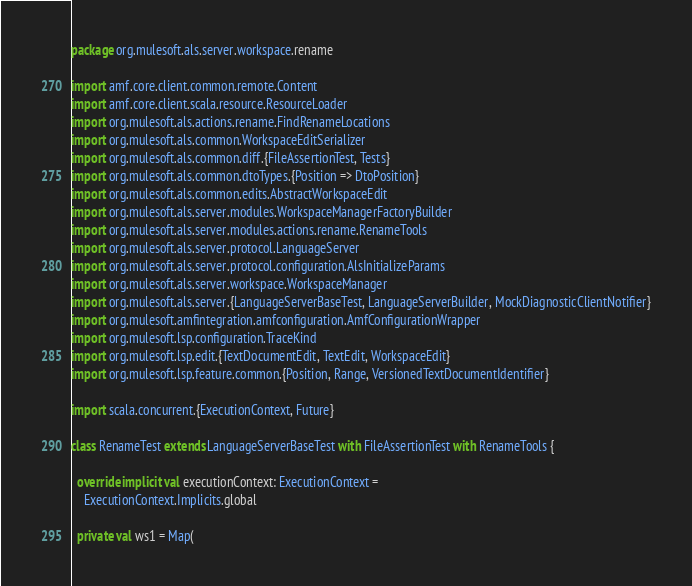<code> <loc_0><loc_0><loc_500><loc_500><_Scala_>package org.mulesoft.als.server.workspace.rename

import amf.core.client.common.remote.Content
import amf.core.client.scala.resource.ResourceLoader
import org.mulesoft.als.actions.rename.FindRenameLocations
import org.mulesoft.als.common.WorkspaceEditSerializer
import org.mulesoft.als.common.diff.{FileAssertionTest, Tests}
import org.mulesoft.als.common.dtoTypes.{Position => DtoPosition}
import org.mulesoft.als.common.edits.AbstractWorkspaceEdit
import org.mulesoft.als.server.modules.WorkspaceManagerFactoryBuilder
import org.mulesoft.als.server.modules.actions.rename.RenameTools
import org.mulesoft.als.server.protocol.LanguageServer
import org.mulesoft.als.server.protocol.configuration.AlsInitializeParams
import org.mulesoft.als.server.workspace.WorkspaceManager
import org.mulesoft.als.server.{LanguageServerBaseTest, LanguageServerBuilder, MockDiagnosticClientNotifier}
import org.mulesoft.amfintegration.amfconfiguration.AmfConfigurationWrapper
import org.mulesoft.lsp.configuration.TraceKind
import org.mulesoft.lsp.edit.{TextDocumentEdit, TextEdit, WorkspaceEdit}
import org.mulesoft.lsp.feature.common.{Position, Range, VersionedTextDocumentIdentifier}

import scala.concurrent.{ExecutionContext, Future}

class RenameTest extends LanguageServerBaseTest with FileAssertionTest with RenameTools {

  override implicit val executionContext: ExecutionContext =
    ExecutionContext.Implicits.global

  private val ws1 = Map(</code> 